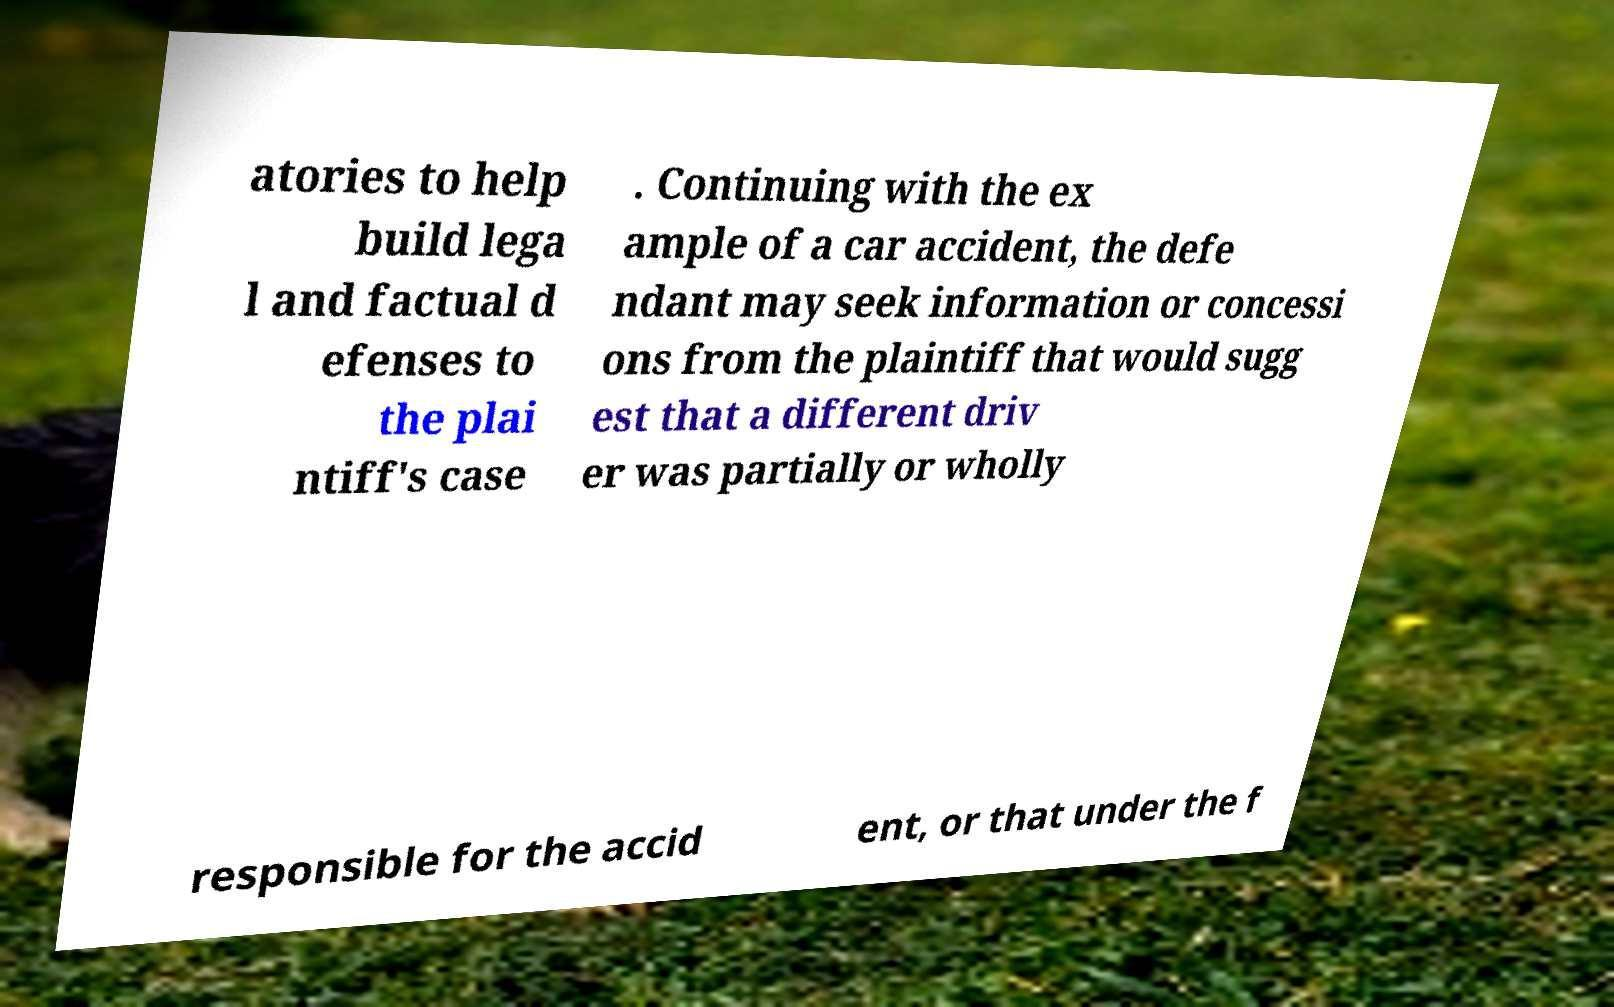Can you accurately transcribe the text from the provided image for me? atories to help build lega l and factual d efenses to the plai ntiff's case . Continuing with the ex ample of a car accident, the defe ndant may seek information or concessi ons from the plaintiff that would sugg est that a different driv er was partially or wholly responsible for the accid ent, or that under the f 